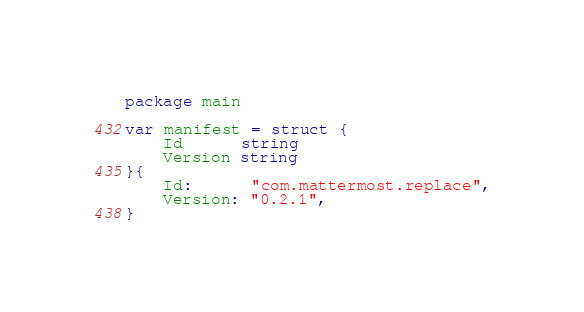<code> <loc_0><loc_0><loc_500><loc_500><_Go_>package main

var manifest = struct {
	Id      string
	Version string
}{
	Id:      "com.mattermost.replace",
	Version: "0.2.1",
}
</code> 